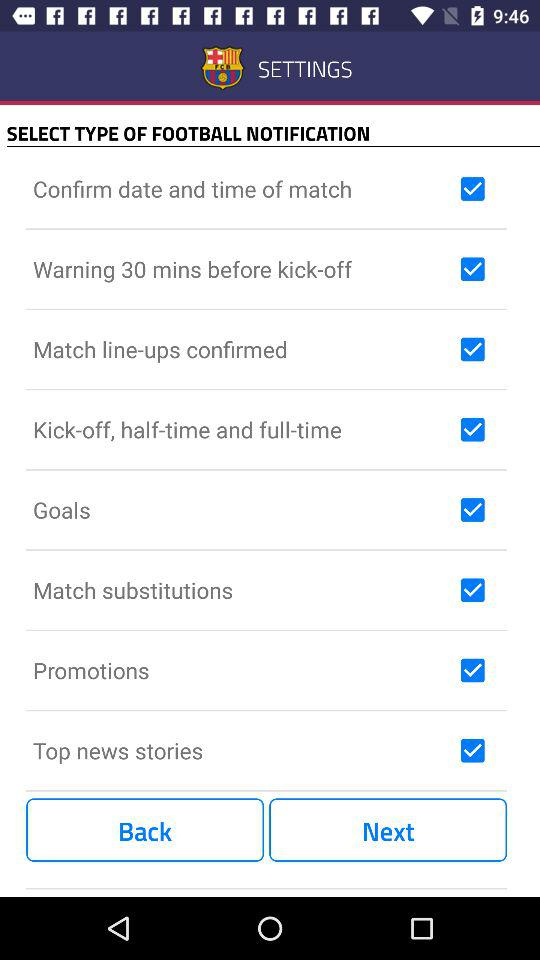What is the status of "Promotions"? The status of "Promotions" is "on". 